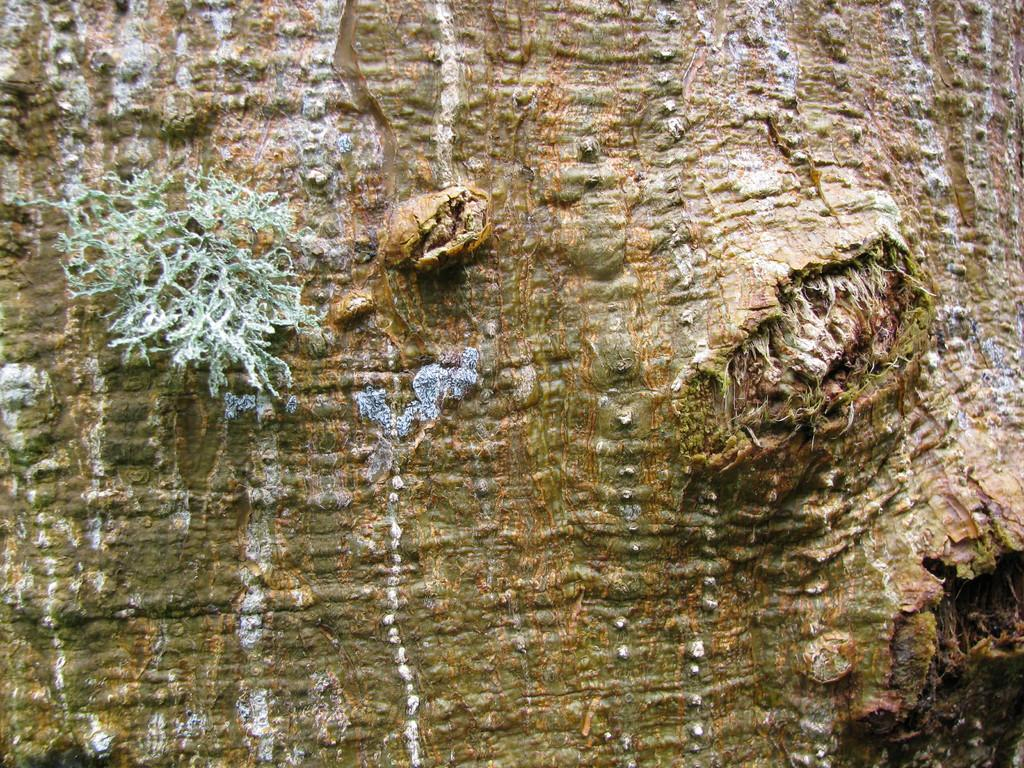What is the main subject of the image? The main subject of the image is a tree trunk. Are there any other plant-related objects in the image? Yes, there is a plant in the image. What type of wave can be seen crashing against the tree trunk in the image? There is no wave present in the image; it features a tree trunk and a plant. What is the stem of the alley in the image? There is no alley or stem mentioned in the image; it only contains a tree trunk and a plant. 